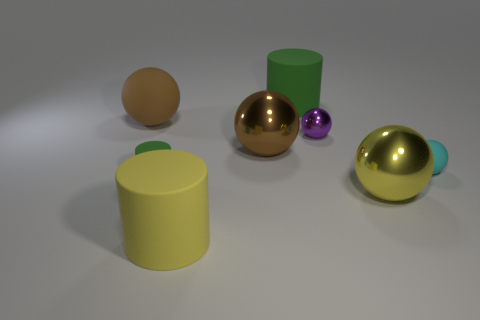Subtract all yellow balls. How many balls are left? 4 Subtract all purple balls. How many balls are left? 4 Subtract all blue spheres. Subtract all purple cubes. How many spheres are left? 5 Add 1 shiny spheres. How many objects exist? 9 Subtract all cylinders. How many objects are left? 5 Subtract 0 cyan cylinders. How many objects are left? 8 Subtract all tiny matte spheres. Subtract all yellow matte things. How many objects are left? 6 Add 8 yellow rubber cylinders. How many yellow rubber cylinders are left? 9 Add 2 brown spheres. How many brown spheres exist? 4 